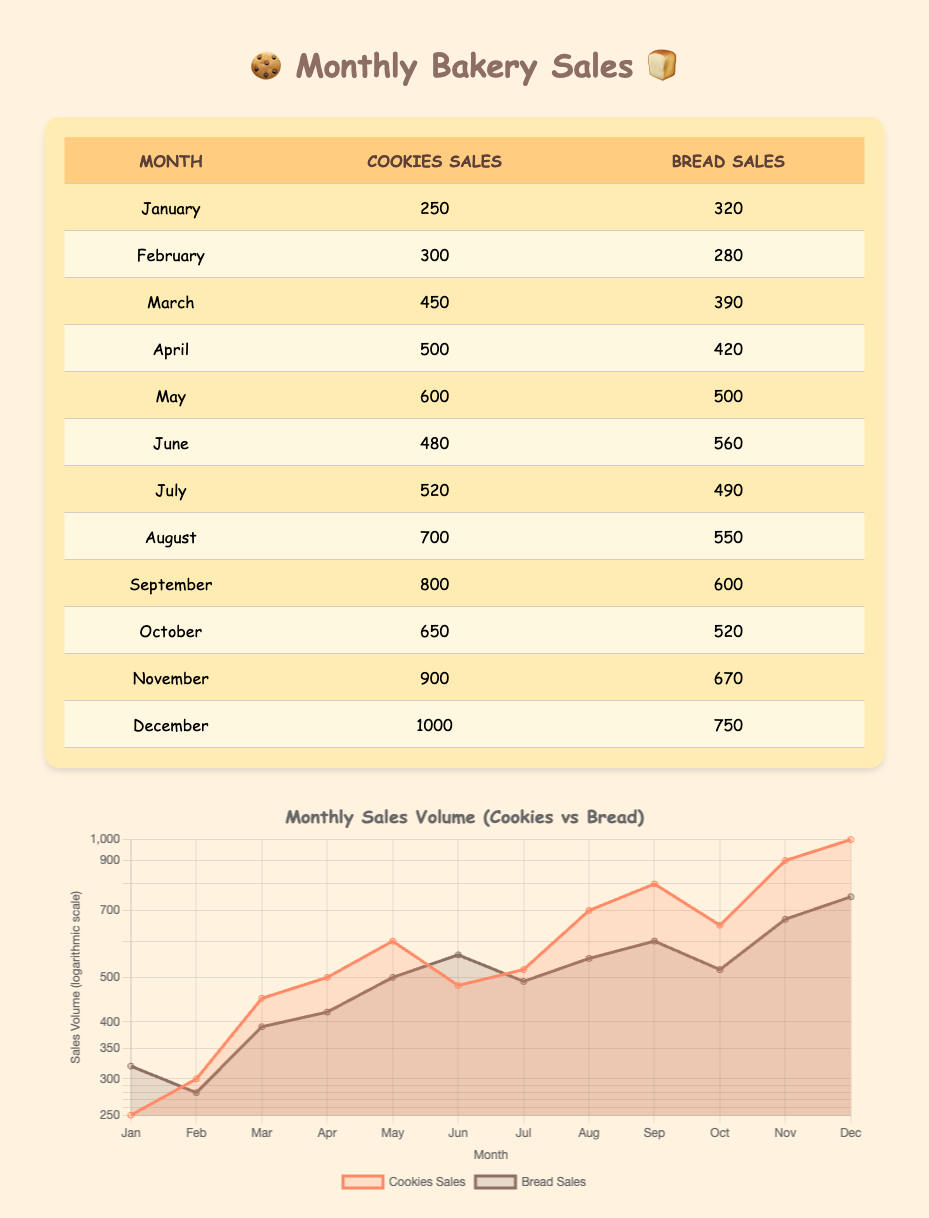What is the total sales volume of cookies in December? The table shows that the cookies sales volume for December is 1000. Therefore, the total sales volume of cookies in December is simply this value.
Answer: 1000 What are the bread sales figures for June? According to the table, the bread sales volume for June is 560. This information is directly provided in the corresponding row for June.
Answer: 560 Is the monthly sales volume of cookies greater than that of bread for all months? By reviewing each month in the table, we find that cookies sales are higher in January, February, March, April, May, August, September, October, November, and December, while bread sales were higher in January and June. Thus, the statement is false for those months.
Answer: No What month had the highest cookies sales volume, and what was that volume? December has the highest cookies sales volume at 1000, as per the data provided in the last row of the table.
Answer: December, 1000 What is the average monthly sales volume of bread over the entire year? To find the average, sum the bread sales volumes over the year: 320 + 280 + 390 + 420 + 500 + 560 + 490 + 550 + 600 + 520 + 670 + 750 = 6,150. Divide this total (6150) by 12 (the number of months), yielding an average of 512.5.
Answer: 512.5 In which month did the bakery sell the most bread, and what was that amount? Upon inspecting the sales volumes for bread listed in each month, we see that the highest sales occurred in December, with a volume of 750, as shown in the final row.
Answer: December, 750 What is the difference between the sales of cookies and bread in November? In November, cookies sales volume is 900, while bread sales volume is 670. The difference can be computed as 900 - 670 = 230.
Answer: 230 Which month had the lowest sales volume for cookies? The lowest sales volume for cookies is found in January, with a sales volume of 250. This information is available in the first row of the table outlining January's sales.
Answer: January, 250 